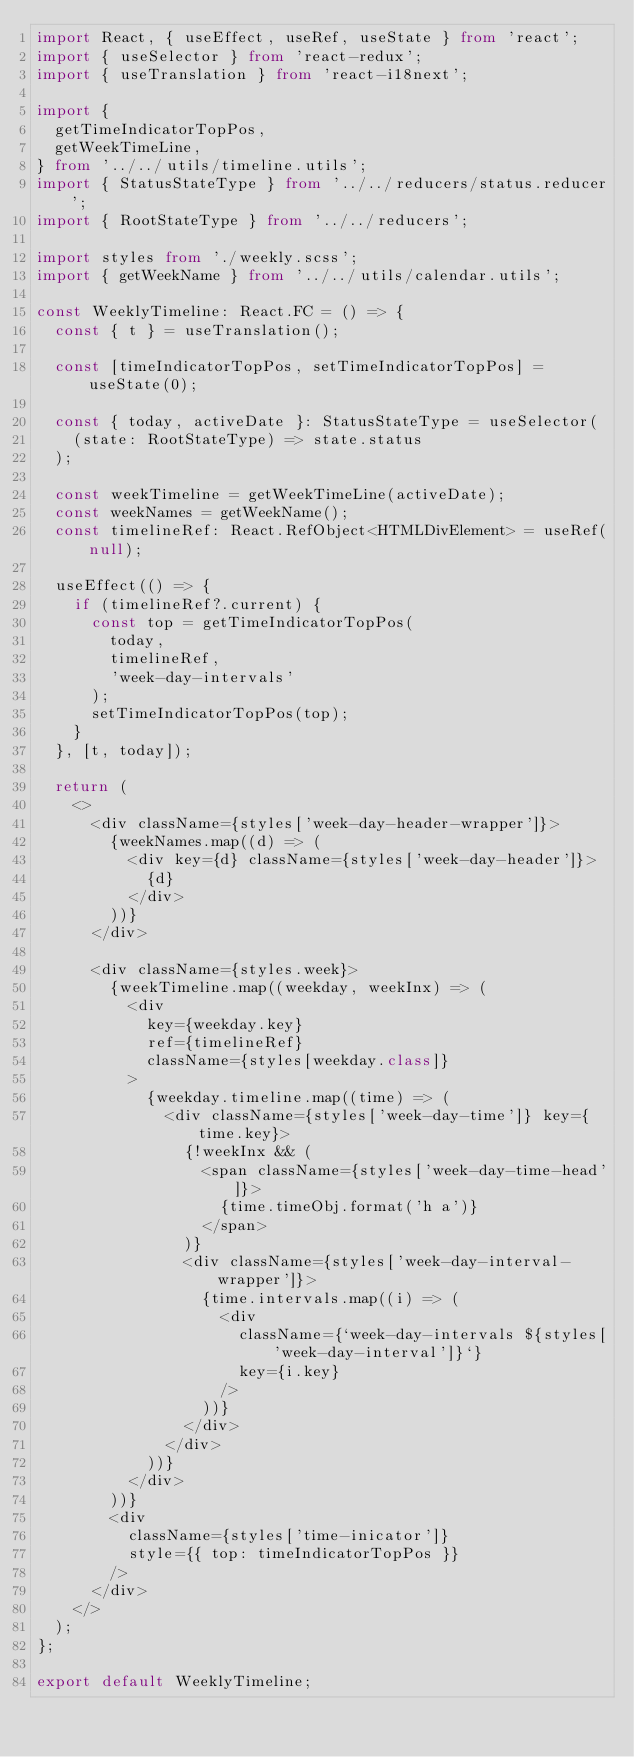Convert code to text. <code><loc_0><loc_0><loc_500><loc_500><_TypeScript_>import React, { useEffect, useRef, useState } from 'react';
import { useSelector } from 'react-redux';
import { useTranslation } from 'react-i18next';

import {
  getTimeIndicatorTopPos,
  getWeekTimeLine,
} from '../../utils/timeline.utils';
import { StatusStateType } from '../../reducers/status.reducer';
import { RootStateType } from '../../reducers';

import styles from './weekly.scss';
import { getWeekName } from '../../utils/calendar.utils';

const WeeklyTimeline: React.FC = () => {
  const { t } = useTranslation();

  const [timeIndicatorTopPos, setTimeIndicatorTopPos] = useState(0);

  const { today, activeDate }: StatusStateType = useSelector(
    (state: RootStateType) => state.status
  );

  const weekTimeline = getWeekTimeLine(activeDate);
  const weekNames = getWeekName();
  const timelineRef: React.RefObject<HTMLDivElement> = useRef(null);

  useEffect(() => {
    if (timelineRef?.current) {
      const top = getTimeIndicatorTopPos(
        today,
        timelineRef,
        'week-day-intervals'
      );
      setTimeIndicatorTopPos(top);
    }
  }, [t, today]);

  return (
    <>
      <div className={styles['week-day-header-wrapper']}>
        {weekNames.map((d) => (
          <div key={d} className={styles['week-day-header']}>
            {d}
          </div>
        ))}
      </div>

      <div className={styles.week}>
        {weekTimeline.map((weekday, weekInx) => (
          <div
            key={weekday.key}
            ref={timelineRef}
            className={styles[weekday.class]}
          >
            {weekday.timeline.map((time) => (
              <div className={styles['week-day-time']} key={time.key}>
                {!weekInx && (
                  <span className={styles['week-day-time-head']}>
                    {time.timeObj.format('h a')}
                  </span>
                )}
                <div className={styles['week-day-interval-wrapper']}>
                  {time.intervals.map((i) => (
                    <div
                      className={`week-day-intervals ${styles['week-day-interval']}`}
                      key={i.key}
                    />
                  ))}
                </div>
              </div>
            ))}
          </div>
        ))}
        <div
          className={styles['time-inicator']}
          style={{ top: timeIndicatorTopPos }}
        />
      </div>
    </>
  );
};

export default WeeklyTimeline;
</code> 